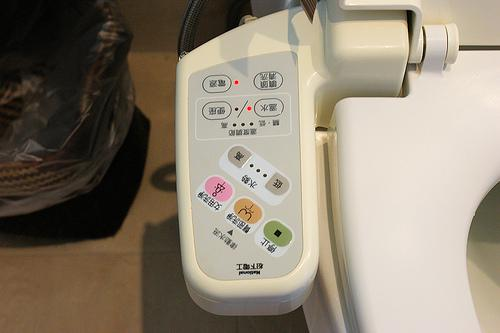Question: where is the photo taken?
Choices:
A. An ice cream parlor.
B. A bathroom.
C. A hospital emergency room.
D. A greenhouse.
Answer with the letter. Answer: B Question: what color is the bottom, middle button?
Choices:
A. Yellow.
B. Red.
C. Green.
D. Blue.
Answer with the letter. Answer: A Question: how many pink buttons are there?
Choices:
A. Two.
B. Three.
C. None.
D. One.
Answer with the letter. Answer: D Question: how many LED lights are lit up?
Choices:
A. 1.
B. 3.
C. 2.
D. 4.
Answer with the letter. Answer: C Question: where is the green button?
Choices:
A. Bottom right.
B. On the top.
C. Under the red button.
D. On the side.
Answer with the letter. Answer: A 